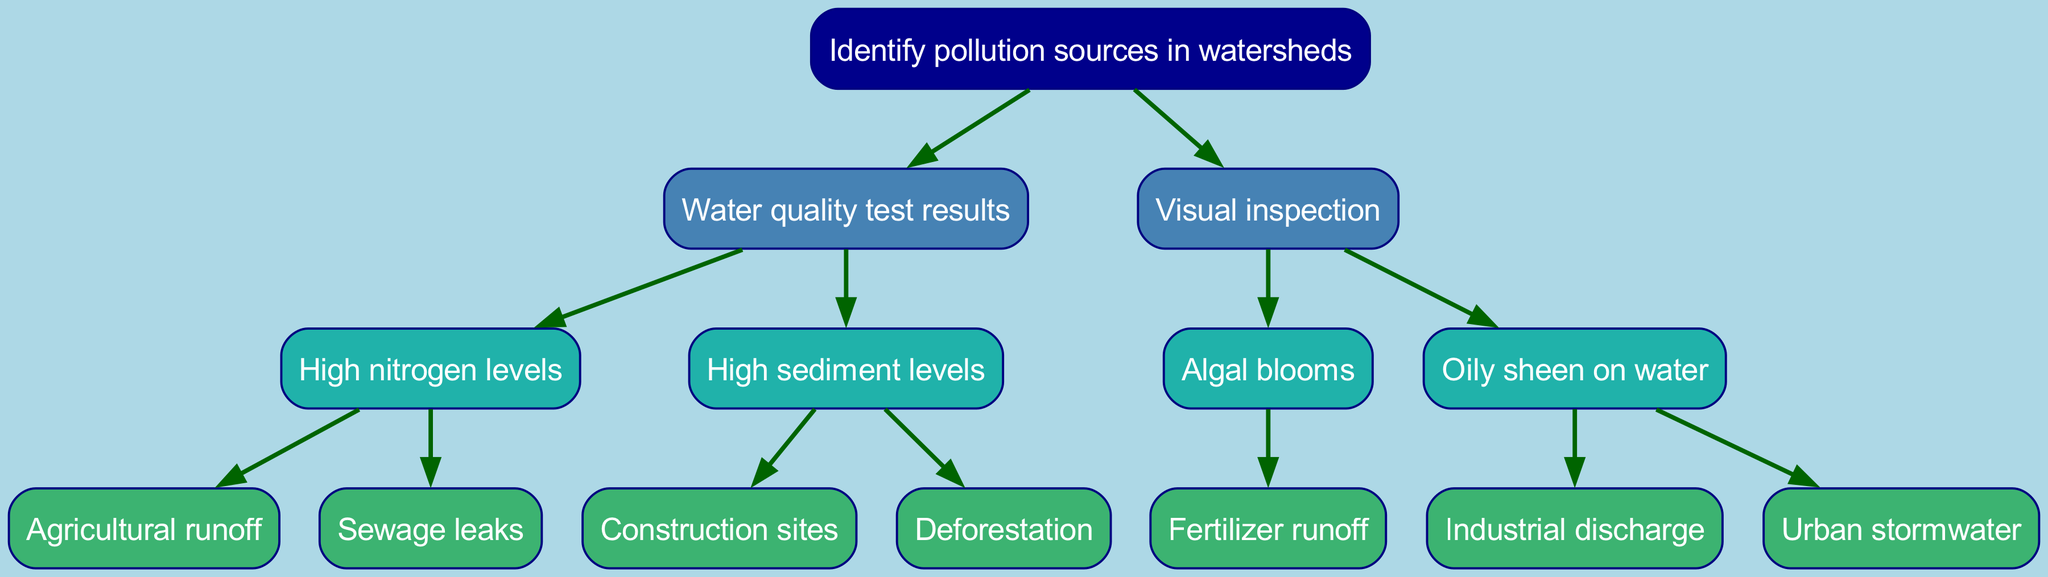What is the main purpose of the diagram? The diagram aims to illustrate the process of identifying pollution sources in watersheds, starting from water quality and visual inspections leading to specific pollution sources.
Answer: Identify pollution sources in watersheds How many direct children does the root node have? The root node has two direct children: "Water quality test results" and "Visual inspection." Thus, the number of children is 2.
Answer: 2 What are the two main categories used to identify pollution sources? The two main categories are "Water quality test results" and "Visual inspection." These categories represent different methods for identifying pollution sources in watersheds.
Answer: Water quality test results, Visual inspection Which pollution source is associated with high nitrogen levels? The pollution sources associated with high nitrogen levels are "Agricultural runoff" and "Sewage leaks," both of which are under the "High nitrogen levels" node.
Answer: Agricultural runoff, Sewage leaks How many pollution sources are identified under high sediment levels? Under high sediment levels, there are two pollution sources mentioned: "Construction sites" and "Deforestation." Therefore, the number of identified pollution sources is 2.
Answer: 2 What pollution source corresponds to algal blooms? The pollution source corresponding to algal blooms is "Fertilizer runoff," which indicates a specific cause of this environmental issue visible during visual inspections.
Answer: Fertilizer runoff What is the connection between high sediment levels and pollution sources? High sediment levels lead to two specific pollution sources: "Construction sites" and "Deforestation." This shows how different activities contribute to sediment-related pollution.
Answer: Construction sites, Deforestation What type of pollution is indicated by the "Oily sheen on water"? The "Oily sheen on water" indicates pollution sources such as "Industrial discharge" and "Urban stormwater," highlighting different origins of this type of pollution.
Answer: Industrial discharge, Urban stormwater How many pollution sources are linked to visual inspection? There are three pollution sources linked to the category of visual inspection: "Fertilizer runoff," "Industrial discharge," and "Urban stormwater." Thus, the total is 3.
Answer: 3 